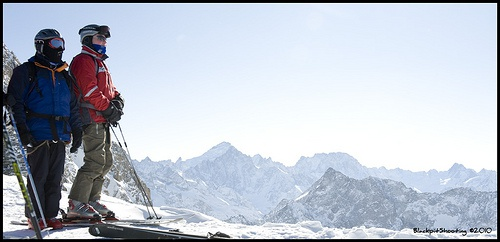Describe the objects in this image and their specific colors. I can see people in black, navy, gray, and maroon tones, people in black, gray, maroon, and lightgray tones, skis in black, gray, and darkgray tones, skis in black, gray, white, and maroon tones, and skis in black, lightgray, darkgray, and gray tones in this image. 